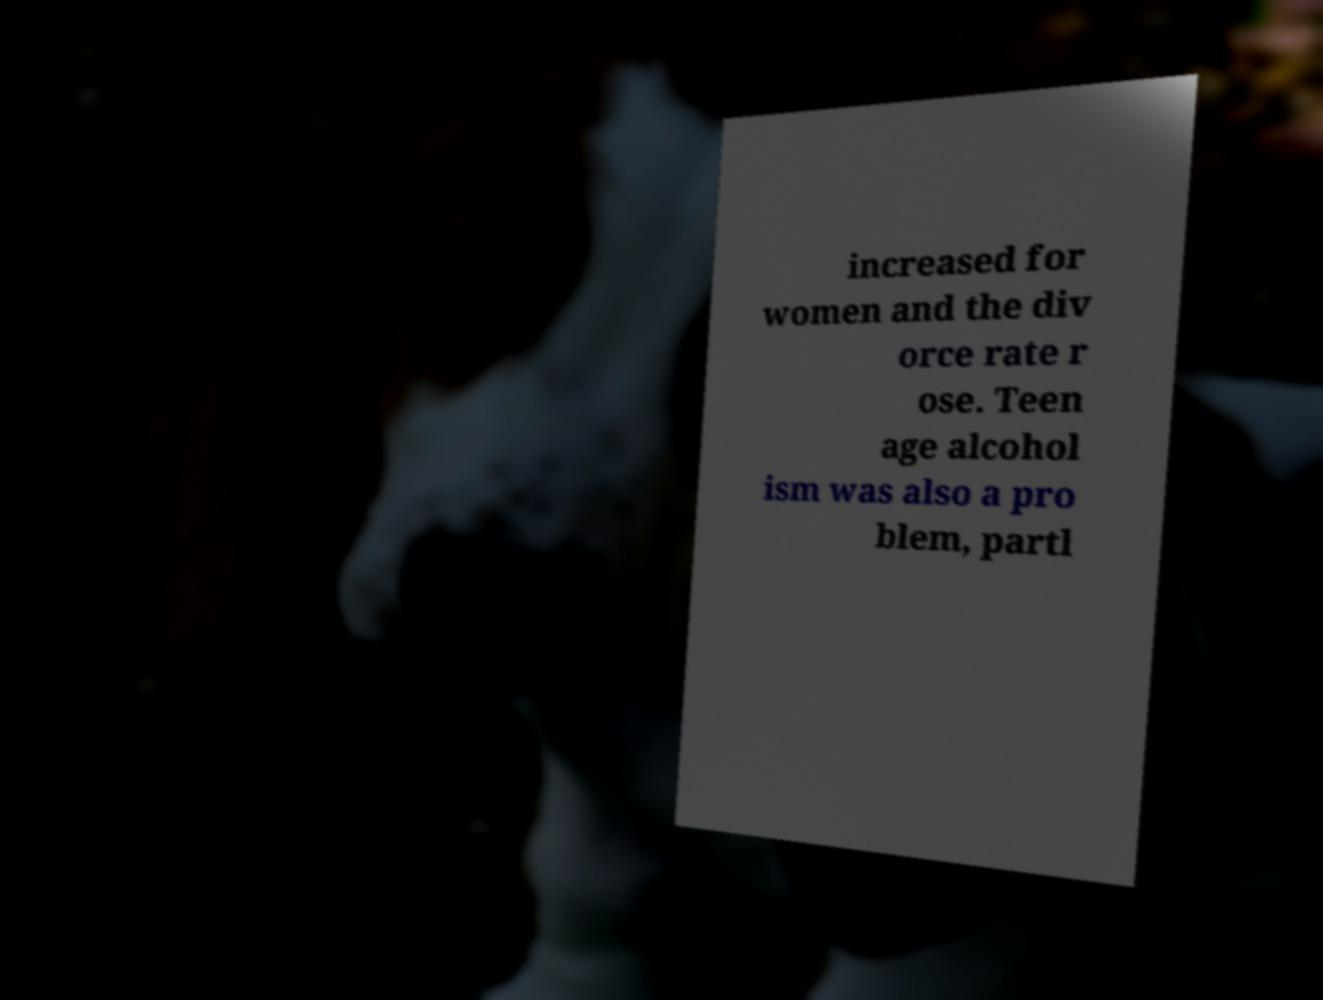Please read and relay the text visible in this image. What does it say? increased for women and the div orce rate r ose. Teen age alcohol ism was also a pro blem, partl 